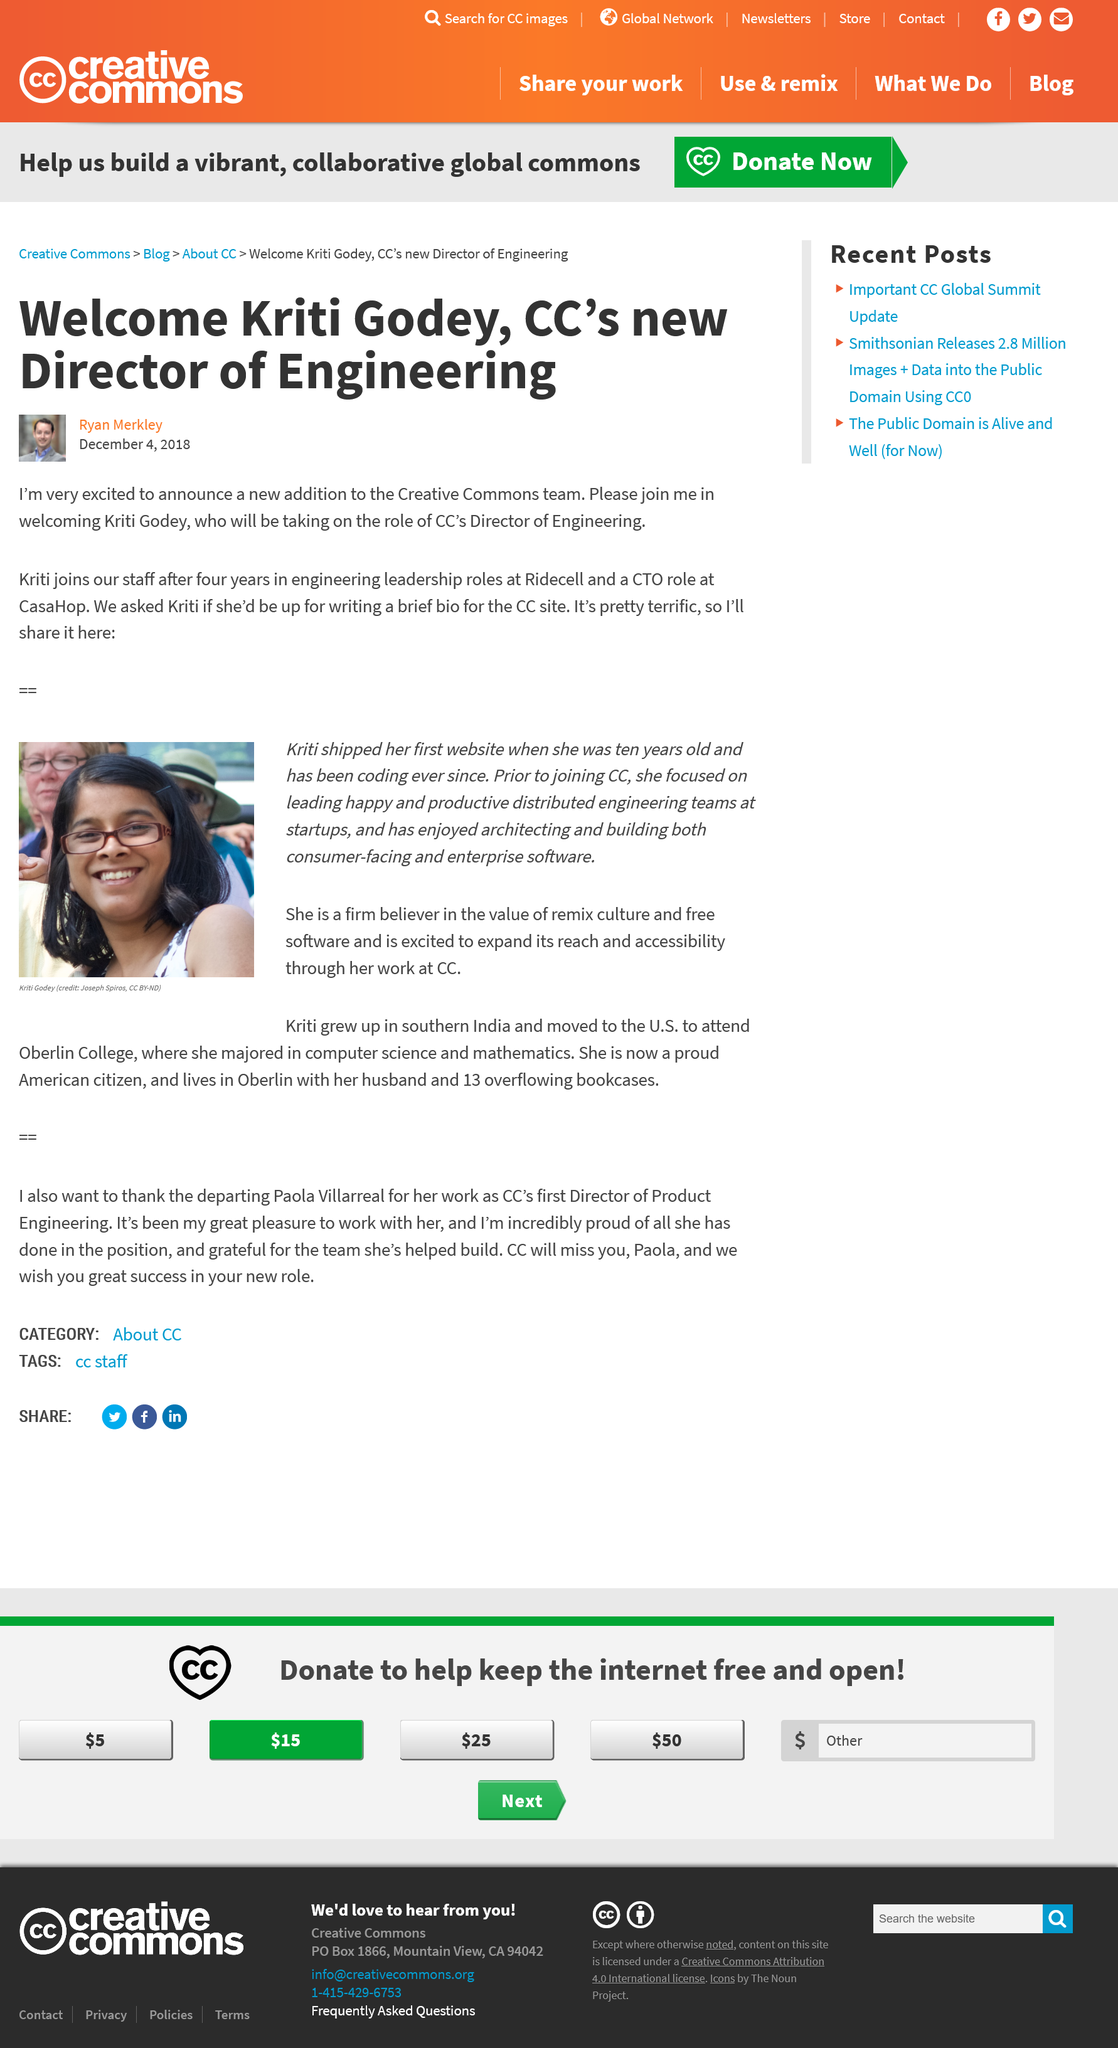Identify some key points in this picture. Kristi, prior to joining CC, focused on leading happy and productive distributed engineering teams at startups, where she excelled in driving success and growth. Kriti had served in other leadership roles for a period of four years. Ryan Merkley wrote the article. Kriti shipped her first website when she was ten years old. Kristi is a firm believer in the value of remix culture and free software. 